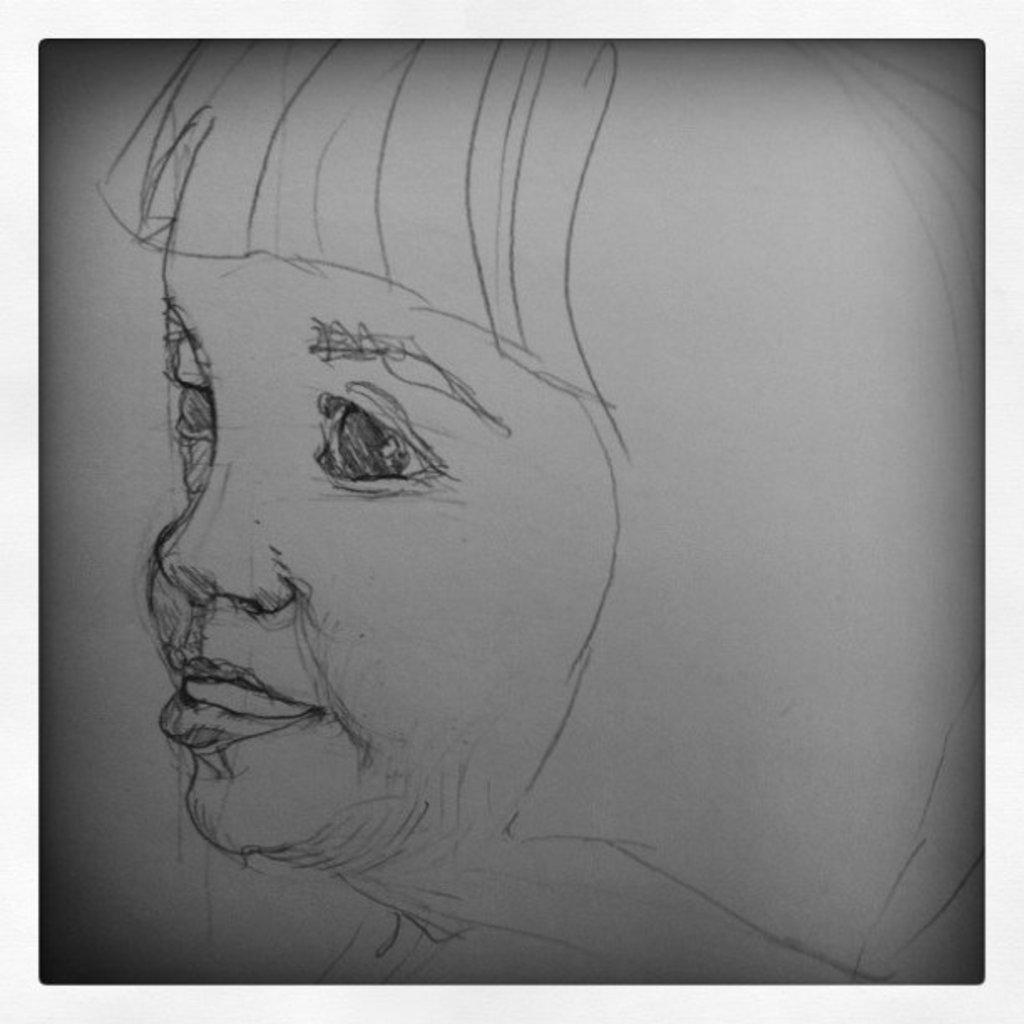What type of image is being shown? The image is an edited picture. What can be seen in the edited picture? There is a sketch of a person in the image. What type of turkey can be seen walking through the door in the image? There is no turkey or door present in the image; it features a sketch of a person. How many cattle are visible in the image? There are no cattle present in the image. 